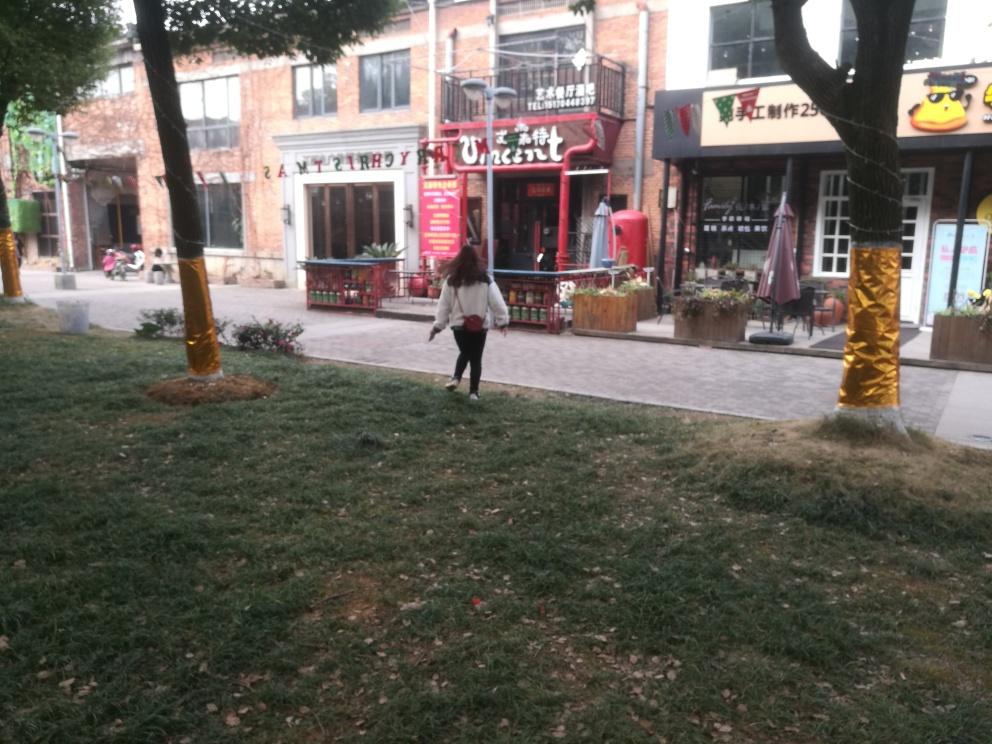What time of day does the image suggest? The lighting in the image suggests that it is daytime, likely late afternoon given the absence of strong shadows and the calmness of the scene. 